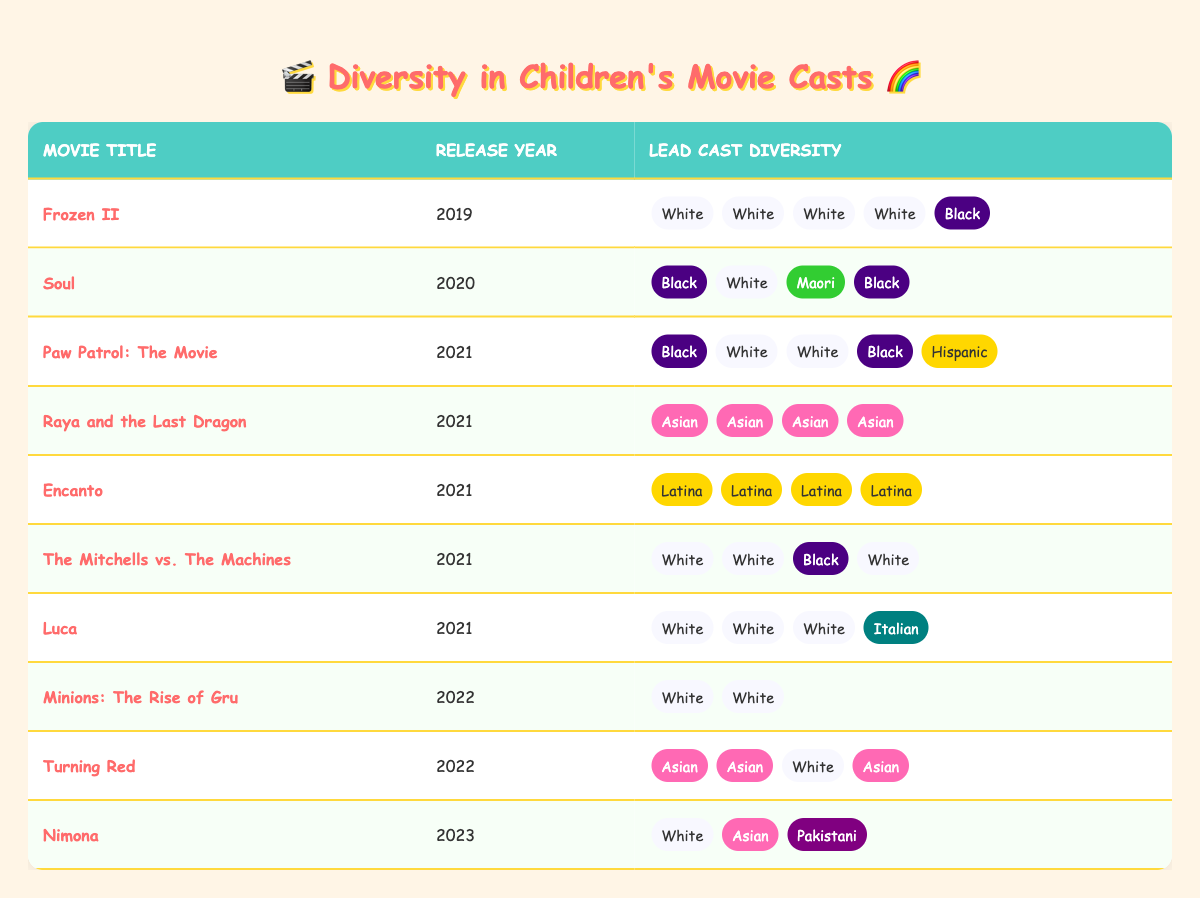What is the release year of "Encanto"? The table lists "Encanto" under the column for release year, showing it as 2021.
Answer: 2021 How many lead cast members in "Frozen II" are of White ethnicity? In the table, "Frozen II" has four cast members labeled as White in the diversity column, making the count four.
Answer: 4 Which movie features the most diverse lead cast in 2021? In the table, "Raya and the Last Dragon" has a lead cast that consists entirely of Asian actors, while "Encanto" features only Latina actors. Both are diverse, but "Raya and the Last Dragon" is completely represented by one ethnicity, interpreting "most diverse" contextually here.
Answer: "Raya and the Last Dragon" How many lead cast members are Asian in "Turning Red"? Checking "Turning Red" in the table, there are three lead cast members identified as Asian, hence the answer is three.
Answer: 3 Does "Minions: The Rise of Gru" have any ethnic diversity in its lead cast? By examining the diversity column for "Minions: The Rise of Gru," it can be seen that all lead cast members are White, indicating no ethnic diversity.
Answer: No What is the total number of unique ethnicities represented in the lead casts across all movies? Analyzing the table, the unique ethnicities present include White, Black, Asian, Hispanic, Latina, Maori, Italian, and Pakistani - totaling eight unique ethnicities.
Answer: 8 Which movie from 2022 features the most lead cast members of Asian ethnicity? The table lists "Turning Red" from 2022 with three lead cast members identified as Asian, while "Minions: The Rise of Gru" features none. Hence, "Turning Red" has the most Asian cast members.
Answer: "Turning Red" Is there a movie from 2021 that features only Black lead cast members? Upon reviewing the data for 2021, "Encanto," "Raya and the Last Dragon," and "Paw Patrol: The Movie" do not feature exclusively Black cast members, hence no such movie exists.
Answer: No Count the total lead cast members for "The Mitchells vs. The Machines". The table indicates that "The Mitchells vs. The Machines" has four lead cast members listed, hence the count is four.
Answer: 4 Which ethnicity has the highest representation in the lead cast of "Luca"? In "Luca," the only ethnicity represented is White, accounting for three lead cast members, along with one Italian representation - resulting in the highest representation: White.
Answer: White 